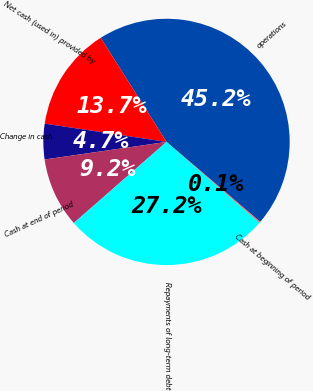Convert chart to OTSL. <chart><loc_0><loc_0><loc_500><loc_500><pie_chart><fcel>operations<fcel>Net cash (used in) provided by<fcel>Change in cash<fcel>Cash at end of period<fcel>Repayments of long-term debt<fcel>Cash at beginning of period<nl><fcel>45.21%<fcel>13.66%<fcel>4.65%<fcel>9.16%<fcel>27.18%<fcel>0.14%<nl></chart> 